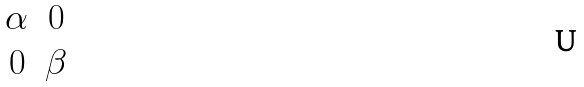Convert formula to latex. <formula><loc_0><loc_0><loc_500><loc_500>\begin{matrix} \alpha & 0 \\ 0 & \beta \end{matrix}</formula> 